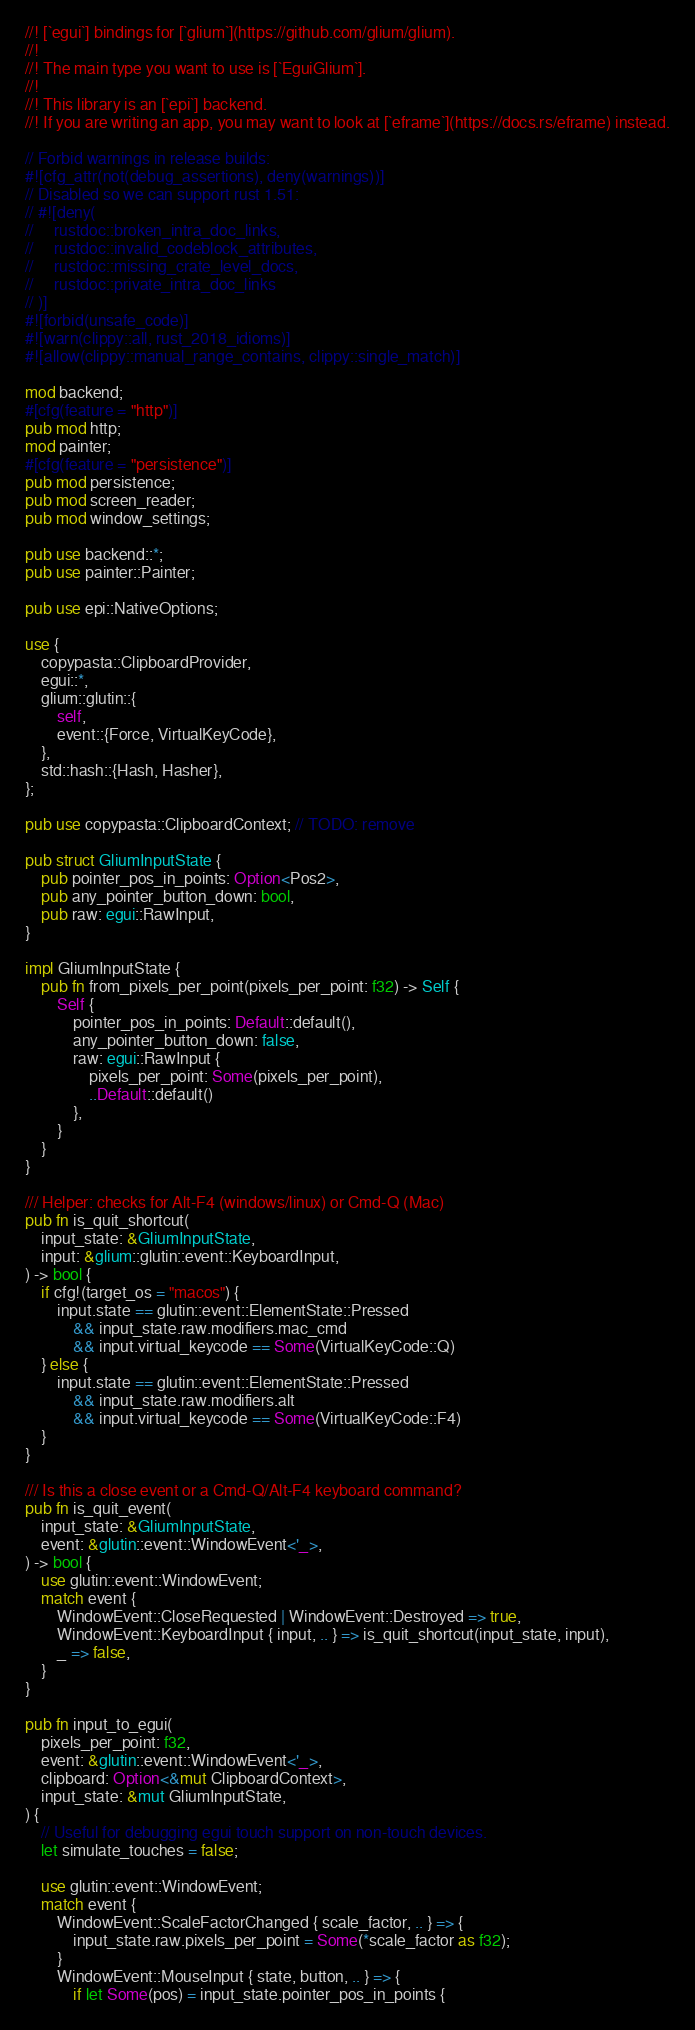Convert code to text. <code><loc_0><loc_0><loc_500><loc_500><_Rust_>//! [`egui`] bindings for [`glium`](https://github.com/glium/glium).
//!
//! The main type you want to use is [`EguiGlium`].
//!
//! This library is an [`epi`] backend.
//! If you are writing an app, you may want to look at [`eframe`](https://docs.rs/eframe) instead.

// Forbid warnings in release builds:
#![cfg_attr(not(debug_assertions), deny(warnings))]
// Disabled so we can support rust 1.51:
// #![deny(
//     rustdoc::broken_intra_doc_links,
//     rustdoc::invalid_codeblock_attributes,
//     rustdoc::missing_crate_level_docs,
//     rustdoc::private_intra_doc_links
// )]
#![forbid(unsafe_code)]
#![warn(clippy::all, rust_2018_idioms)]
#![allow(clippy::manual_range_contains, clippy::single_match)]

mod backend;
#[cfg(feature = "http")]
pub mod http;
mod painter;
#[cfg(feature = "persistence")]
pub mod persistence;
pub mod screen_reader;
pub mod window_settings;

pub use backend::*;
pub use painter::Painter;

pub use epi::NativeOptions;

use {
    copypasta::ClipboardProvider,
    egui::*,
    glium::glutin::{
        self,
        event::{Force, VirtualKeyCode},
    },
    std::hash::{Hash, Hasher},
};

pub use copypasta::ClipboardContext; // TODO: remove

pub struct GliumInputState {
    pub pointer_pos_in_points: Option<Pos2>,
    pub any_pointer_button_down: bool,
    pub raw: egui::RawInput,
}

impl GliumInputState {
    pub fn from_pixels_per_point(pixels_per_point: f32) -> Self {
        Self {
            pointer_pos_in_points: Default::default(),
            any_pointer_button_down: false,
            raw: egui::RawInput {
                pixels_per_point: Some(pixels_per_point),
                ..Default::default()
            },
        }
    }
}

/// Helper: checks for Alt-F4 (windows/linux) or Cmd-Q (Mac)
pub fn is_quit_shortcut(
    input_state: &GliumInputState,
    input: &glium::glutin::event::KeyboardInput,
) -> bool {
    if cfg!(target_os = "macos") {
        input.state == glutin::event::ElementState::Pressed
            && input_state.raw.modifiers.mac_cmd
            && input.virtual_keycode == Some(VirtualKeyCode::Q)
    } else {
        input.state == glutin::event::ElementState::Pressed
            && input_state.raw.modifiers.alt
            && input.virtual_keycode == Some(VirtualKeyCode::F4)
    }
}

/// Is this a close event or a Cmd-Q/Alt-F4 keyboard command?
pub fn is_quit_event(
    input_state: &GliumInputState,
    event: &glutin::event::WindowEvent<'_>,
) -> bool {
    use glutin::event::WindowEvent;
    match event {
        WindowEvent::CloseRequested | WindowEvent::Destroyed => true,
        WindowEvent::KeyboardInput { input, .. } => is_quit_shortcut(input_state, input),
        _ => false,
    }
}

pub fn input_to_egui(
    pixels_per_point: f32,
    event: &glutin::event::WindowEvent<'_>,
    clipboard: Option<&mut ClipboardContext>,
    input_state: &mut GliumInputState,
) {
    // Useful for debugging egui touch support on non-touch devices.
    let simulate_touches = false;

    use glutin::event::WindowEvent;
    match event {
        WindowEvent::ScaleFactorChanged { scale_factor, .. } => {
            input_state.raw.pixels_per_point = Some(*scale_factor as f32);
        }
        WindowEvent::MouseInput { state, button, .. } => {
            if let Some(pos) = input_state.pointer_pos_in_points {</code> 